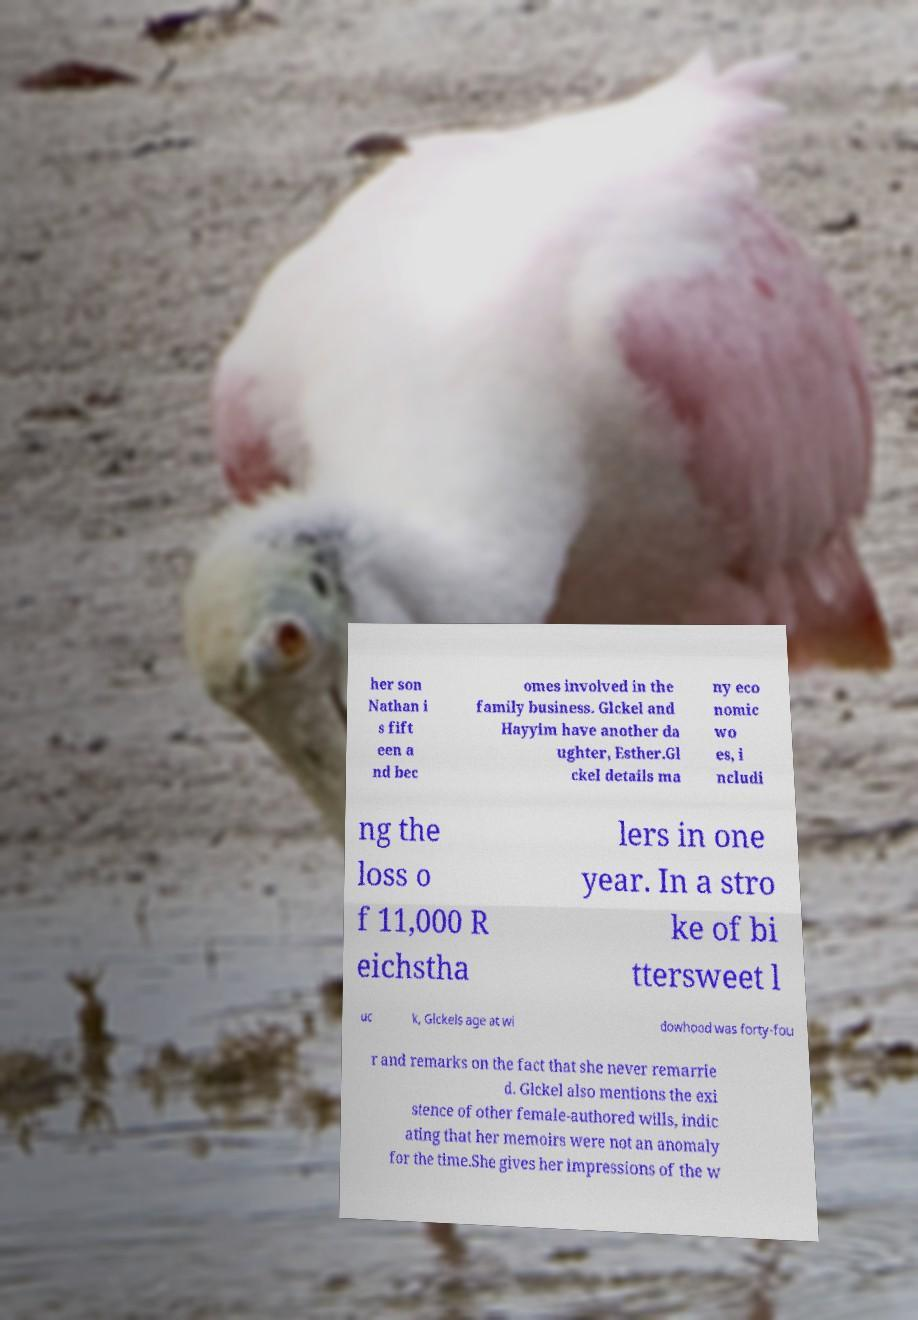What messages or text are displayed in this image? I need them in a readable, typed format. her son Nathan i s fift een a nd bec omes involved in the family business. Glckel and Hayyim have another da ughter, Esther.Gl ckel details ma ny eco nomic wo es, i ncludi ng the loss o f 11,000 R eichstha lers in one year. In a stro ke of bi ttersweet l uc k, Glckels age at wi dowhood was forty-fou r and remarks on the fact that she never remarrie d. Glckel also mentions the exi stence of other female-authored wills, indic ating that her memoirs were not an anomaly for the time.She gives her impressions of the w 